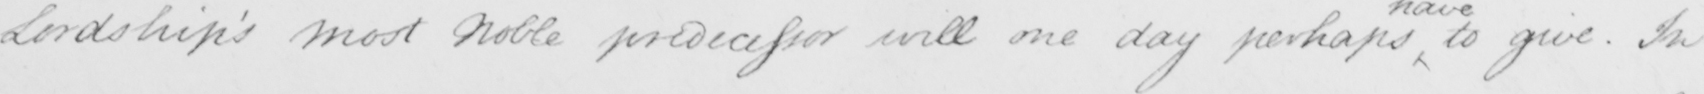What text is written in this handwritten line? Lordship ' s Most Noble predecessor will one day perhaps to give . In 